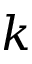<formula> <loc_0><loc_0><loc_500><loc_500>k</formula> 